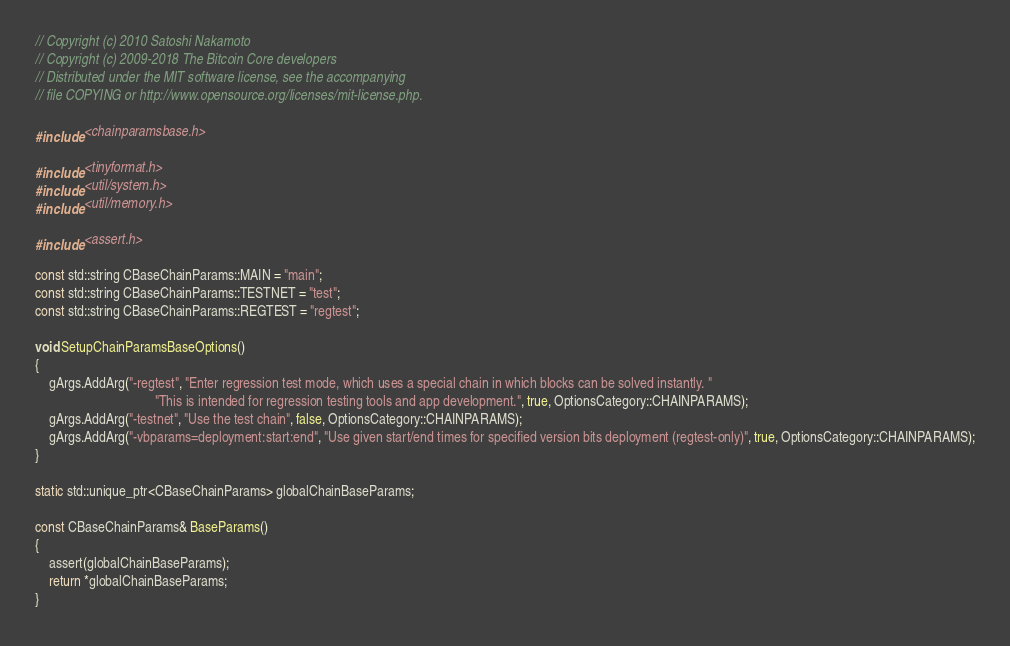Convert code to text. <code><loc_0><loc_0><loc_500><loc_500><_C++_>// Copyright (c) 2010 Satoshi Nakamoto
// Copyright (c) 2009-2018 The Bitcoin Core developers
// Distributed under the MIT software license, see the accompanying
// file COPYING or http://www.opensource.org/licenses/mit-license.php.

#include <chainparamsbase.h>

#include <tinyformat.h>
#include <util/system.h>
#include <util/memory.h>

#include <assert.h>

const std::string CBaseChainParams::MAIN = "main";
const std::string CBaseChainParams::TESTNET = "test";
const std::string CBaseChainParams::REGTEST = "regtest";

void SetupChainParamsBaseOptions()
{
    gArgs.AddArg("-regtest", "Enter regression test mode, which uses a special chain in which blocks can be solved instantly. "
                                   "This is intended for regression testing tools and app development.", true, OptionsCategory::CHAINPARAMS);
    gArgs.AddArg("-testnet", "Use the test chain", false, OptionsCategory::CHAINPARAMS);
    gArgs.AddArg("-vbparams=deployment:start:end", "Use given start/end times for specified version bits deployment (regtest-only)", true, OptionsCategory::CHAINPARAMS);
}

static std::unique_ptr<CBaseChainParams> globalChainBaseParams;

const CBaseChainParams& BaseParams()
{
    assert(globalChainBaseParams);
    return *globalChainBaseParams;
}
</code> 